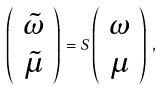<formula> <loc_0><loc_0><loc_500><loc_500>\left ( \begin{array} { c } \tilde { \omega } \\ \tilde { \mu } \end{array} \right ) = S \left ( \begin{array} { c } \omega \\ \mu \end{array} \right ) \, ,</formula> 